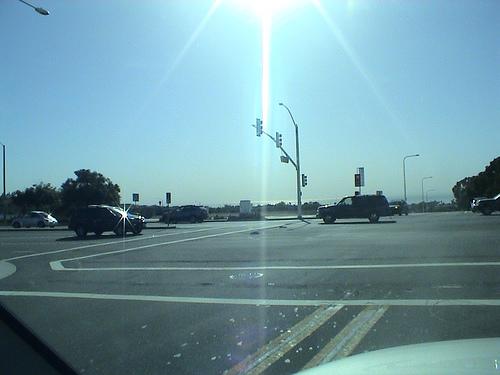Is this in the city?
Answer briefly. Yes. Where is the sun in this picture?
Give a very brief answer. At top. What color is the traffic light?
Keep it brief. Red. Was this taken at night?
Quick response, please. No. How many street lights are there?
Quick response, please. 4. 